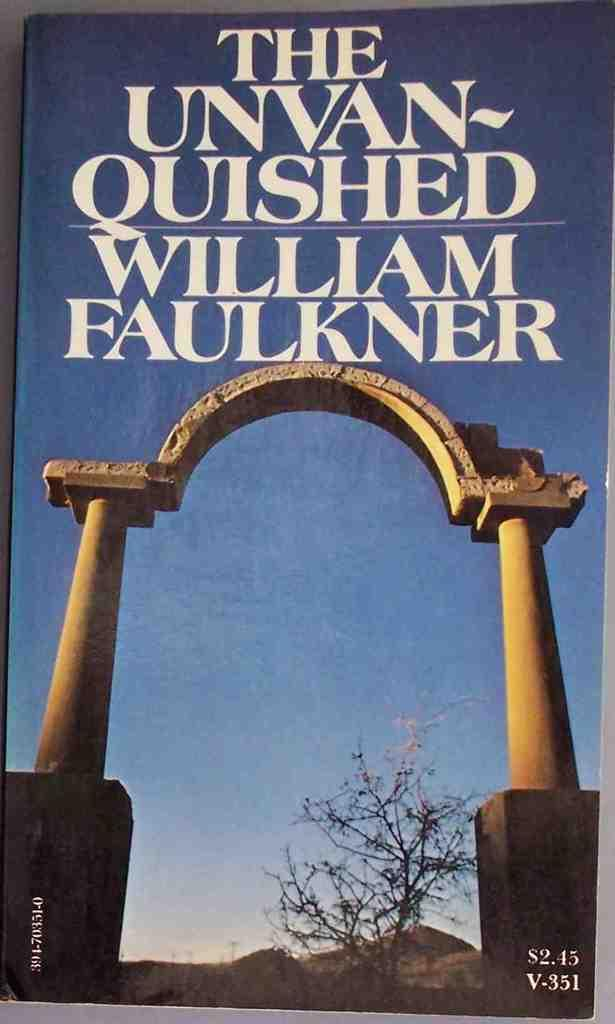What is the main subject of the image? The main subject of the image is a book cover. What design element can be seen on the book cover? There is an arch on the book cover. What type of object is at the bottom of the image? There is a plant at the bottom of the image. What can be read or seen at the top of the image? There is text visible at the top of the image. How many hands are holding the book cover in the image? There are no hands visible in the image, as it only features a book cover with an arch, a plant, and text. 